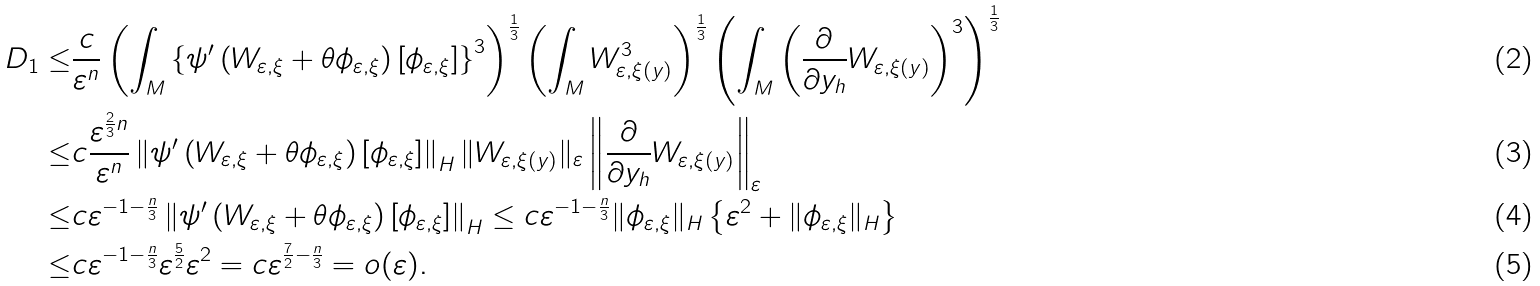<formula> <loc_0><loc_0><loc_500><loc_500>D _ { 1 } \leq & \frac { c } { \varepsilon ^ { n } } \left ( \int _ { M } \left \{ \psi ^ { \prime } \left ( W _ { \varepsilon , \xi } + \theta \phi _ { \varepsilon , \xi } \right ) \left [ \phi _ { \varepsilon , \xi } \right ] \right \} ^ { 3 } \right ) ^ { \frac { 1 } { 3 } } \left ( \int _ { M } W _ { \varepsilon , \xi ( y ) } ^ { 3 } \right ) ^ { \frac { 1 } { 3 } } \left ( \int _ { M } \left ( \frac { \partial } { \partial y _ { h } } W _ { \varepsilon , \xi ( y ) } \right ) ^ { 3 } \right ) ^ { \frac { 1 } { 3 } } \\ \leq & c \frac { \varepsilon ^ { \frac { 2 } { 3 } n } } { \varepsilon ^ { n } } \left \| \psi ^ { \prime } \left ( W _ { \varepsilon , \xi } + \theta \phi _ { \varepsilon , \xi } \right ) \left [ \phi _ { \varepsilon , \xi } \right ] \right \| _ { H } \| W _ { \varepsilon , \xi ( y ) } \| _ { \varepsilon } \left \| \frac { \partial } { \partial y _ { h } } W _ { \varepsilon , \xi ( y ) } \right \| _ { \varepsilon } \\ \leq & c \varepsilon ^ { - 1 - \frac { n } { 3 } } \left \| \psi ^ { \prime } \left ( W _ { \varepsilon , \xi } + \theta \phi _ { \varepsilon , \xi } \right ) \left [ \phi _ { \varepsilon , \xi } \right ] \right \| _ { H } \leq c \varepsilon ^ { - 1 - \frac { n } { 3 } } \| \phi _ { \varepsilon , \xi } \| _ { H } \left \{ \varepsilon ^ { 2 } + \| \phi _ { \varepsilon , \xi } \| _ { H } \right \} \\ \leq & c \varepsilon ^ { - 1 - \frac { n } { 3 } } \varepsilon ^ { \frac { 5 } { 2 } } \varepsilon ^ { 2 } = c \varepsilon ^ { \frac { 7 } { 2 } - \frac { n } { 3 } } = o ( \varepsilon ) .</formula> 